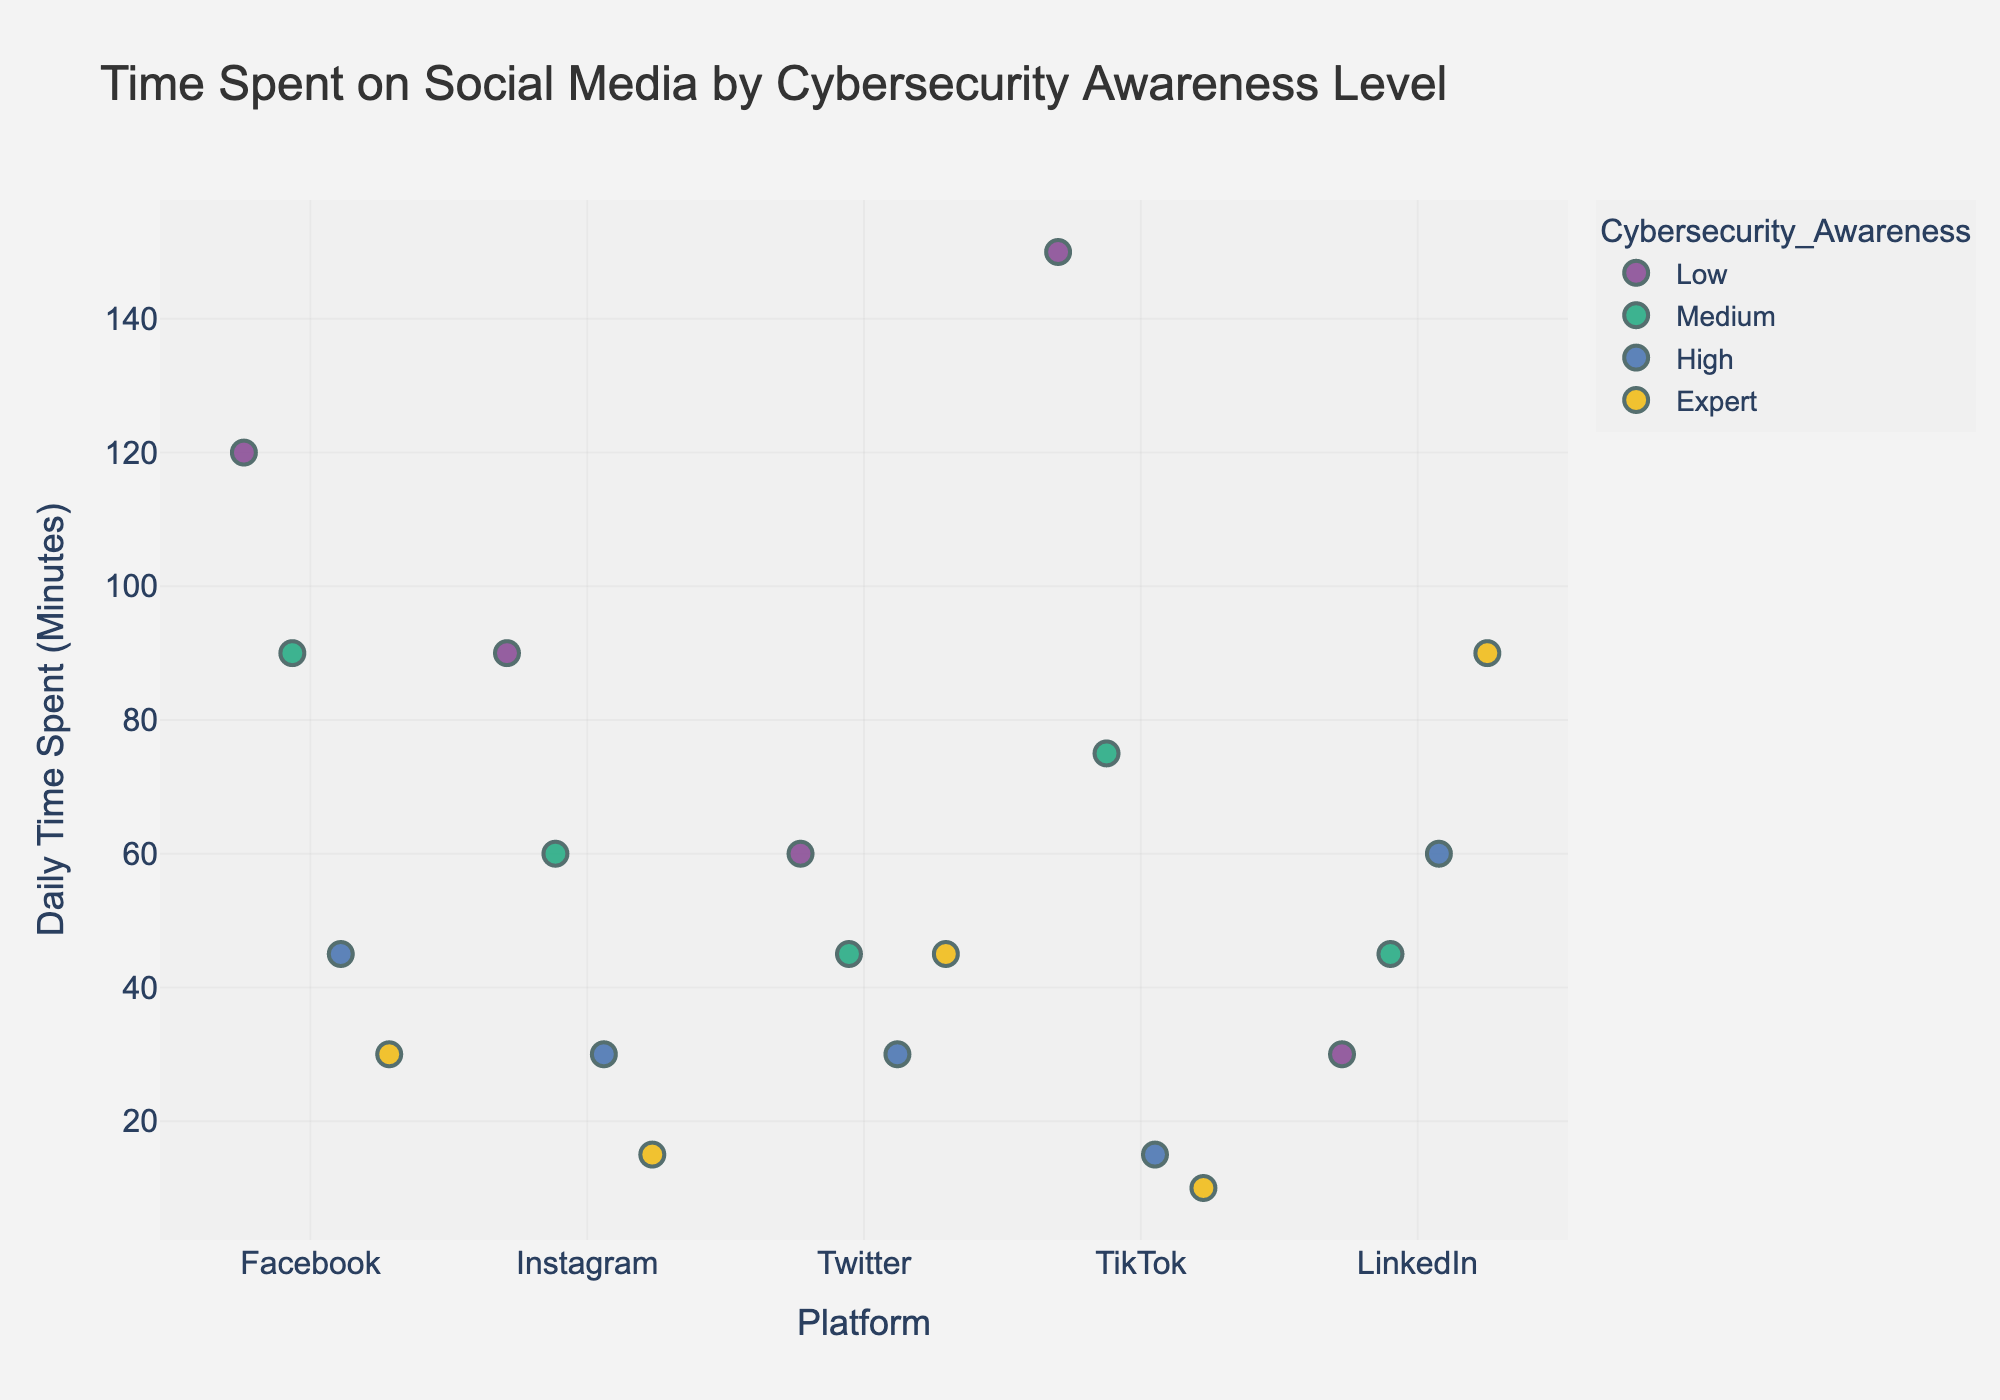What is the title of the plot? The title is usually placed at the top of the plot, providing a summary of what the plot represents. In this case, it indicates the comparison of time spent on social media by individuals with different levels of cybersecurity awareness.
Answer: Time Spent on Social Media by Cybersecurity Awareness Level Which cybersecurity awareness level spends the most time on Facebook daily? By observing the strip plot data points on the Facebook axis, identify which awareness level corresponds to the highest value on the y-axis (Daily Time Spent in Minutes).
Answer: Low How do the time spent on Instagram by individuals with high cybersecurity awareness compare to those with medium awareness? Locate the data points for Instagram on the x-axis for both high and medium awareness levels. Compare the y-axis values of these points. High awareness shows a value of 30 minutes, whereas medium awareness shows a value of 60 minutes.
Answer: High awareness spends less time than medium awareness What is the range of time spent daily on TikTok for the low cybersecurity awareness group? Identify all the data points corresponding to the low awareness category and TikTok on the x-axis. The range is calculated by finding the difference between the maximum and minimum values of these points.
Answer: 150 - 150 = 150 Which platform do experts spend the least time on daily? Examine the data points for experts (denoted by colour) across all platforms on the x-axis. Identify the smallest value on the y-axis among these points.
Answer: TikTok What is the average time spent on social media platforms by individuals with medium cybersecurity awareness? Find all data points for the medium cybersecurity awareness level and calculate the average of their y-axis values. The values are 90, 60, 45, 75, and 45. Sum these values (90 + 60 + 45 + 75 + 45 = 315) and divide by the number of points (315/5).
Answer: 63 minutes Compare the time spent on LinkedIn by individuals with expert and high cybersecurity awareness levels. Find the data points for LinkedIn along the x-axis and compare the y-axis values corresponding to expert and high levels. Experts spend 90 minutes, whereas high awareness individuals spend 60 minutes.
Answer: Experts spend more time than high Which platform shows the widest spread in time spent by individuals with low cybersecurity awareness? Look for the platform with the largest difference between the maximum and minimum data points for individuals with low cybersecurity awareness. Compare the spreads for Facebook, Instagram, Twitter, TikTok, and LinkedIn. TikTok has the widest spread due to having both a high (150 minutes) and low (also 150 minutes) usage value, leading to a larger visual spread on the plot.
Answer: TikTok Is there a platform where time spent by individuals with high cybersecurity awareness exceeds that of individuals with low awareness? Compare the maximum time spent (y-axis values) per platform across high and low cybersecurity awareness levels. Check Facebook, Instagram, Twitter, TikTok, and LinkedIn for this condition. For LinkedIn, high awareness individuals spend 60 minutes, which is more than low awareness at 30 minutes.
Answer: Yes, LinkedIn 